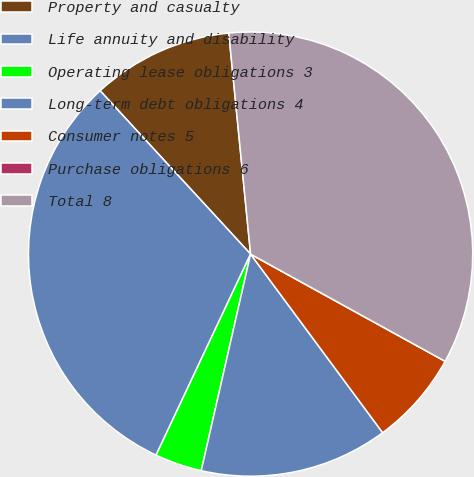<chart> <loc_0><loc_0><loc_500><loc_500><pie_chart><fcel>Property and casualty<fcel>Life annuity and disability<fcel>Operating lease obligations 3<fcel>Long-term debt obligations 4<fcel>Consumer notes 5<fcel>Purchase obligations 6<fcel>Total 8<nl><fcel>10.28%<fcel>31.16%<fcel>3.43%<fcel>13.7%<fcel>6.85%<fcel>0.0%<fcel>34.58%<nl></chart> 